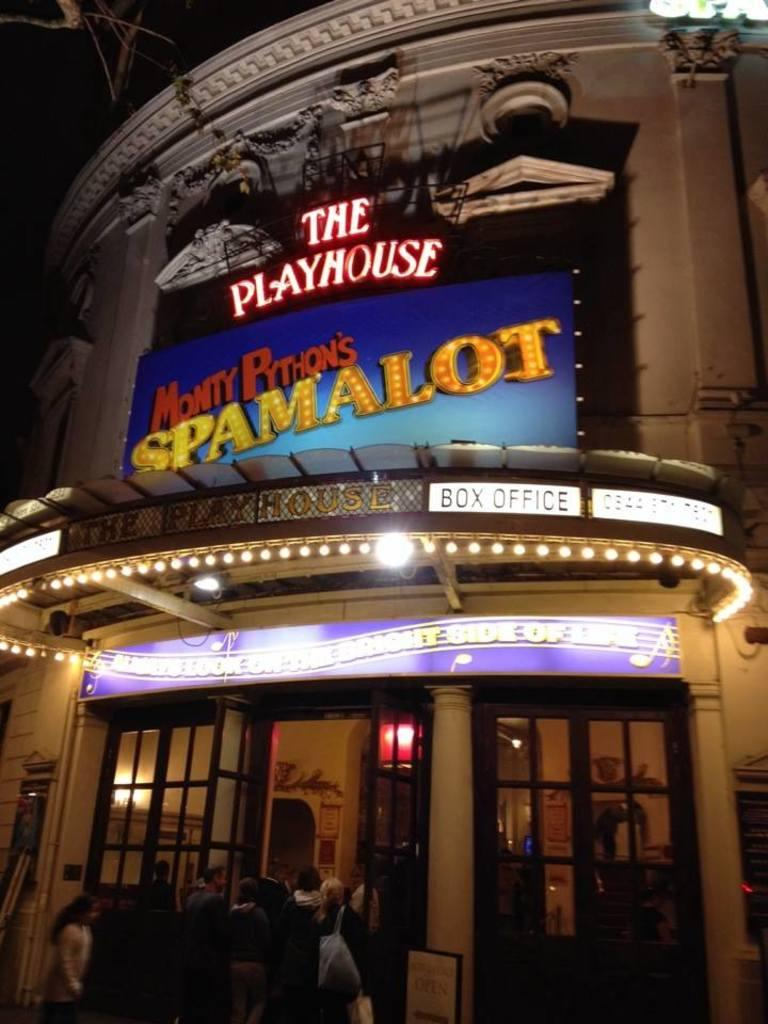How many people are in the image? There is a group of people in the image, but the exact number cannot be determined from the provided facts. What can be seen on the name boards in the image? The name boards in the image contain names or labels, but the specific information cannot be determined from the provided facts. What type of building is in the image? The building in the image is not described in detail, so its type cannot be determined from the provided facts. What kind of lights are in the image? The lights in the image are not described in detail, so their type cannot be determined from the provided facts. What can be seen through the windows in the image? The windows in the image are not described in detail, so what can be seen through them cannot be determined from the provided facts. What objects are in the image? There are some objects in the image, but their specific nature cannot be determined from the provided facts. What color of paint is being used to fix the wrench in the image? There is no paint or wrench present in the image, so this question cannot be answered. 